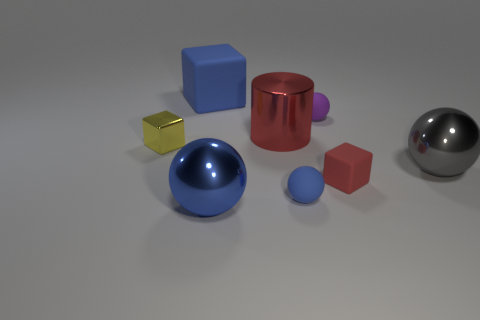Add 2 blue objects. How many objects exist? 10 Subtract all cylinders. How many objects are left? 7 Add 7 yellow metallic blocks. How many yellow metallic blocks are left? 8 Add 1 green rubber blocks. How many green rubber blocks exist? 1 Subtract 0 gray cubes. How many objects are left? 8 Subtract all large blue matte things. Subtract all big blue blocks. How many objects are left? 6 